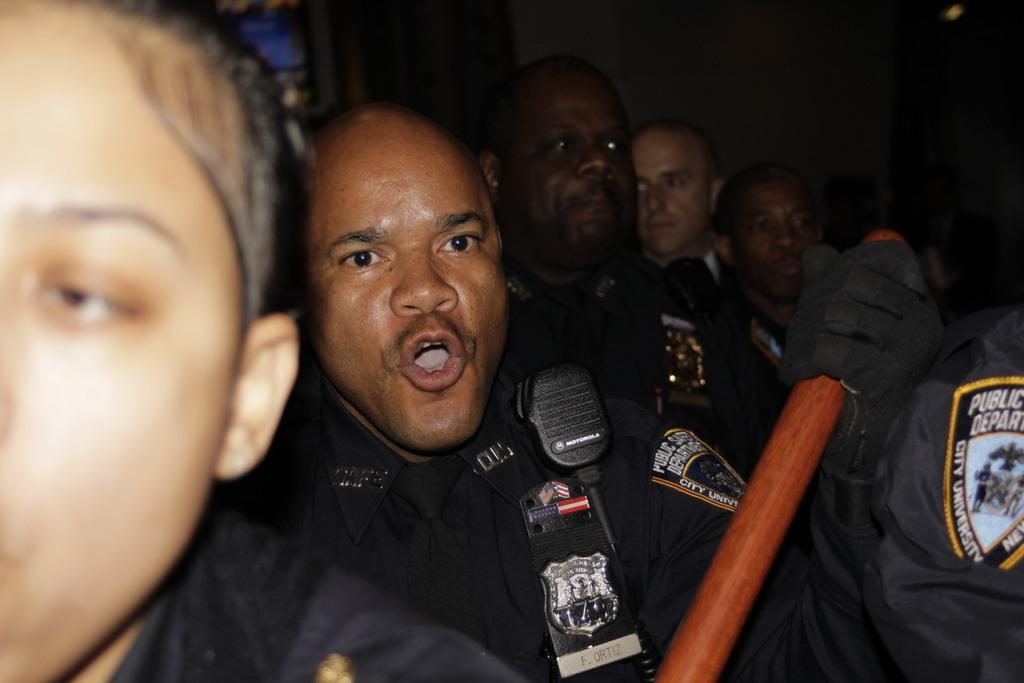In one or two sentences, can you explain what this image depicts? In this image we can see a group of persons, and the person in the middle is holding a wooden object. 